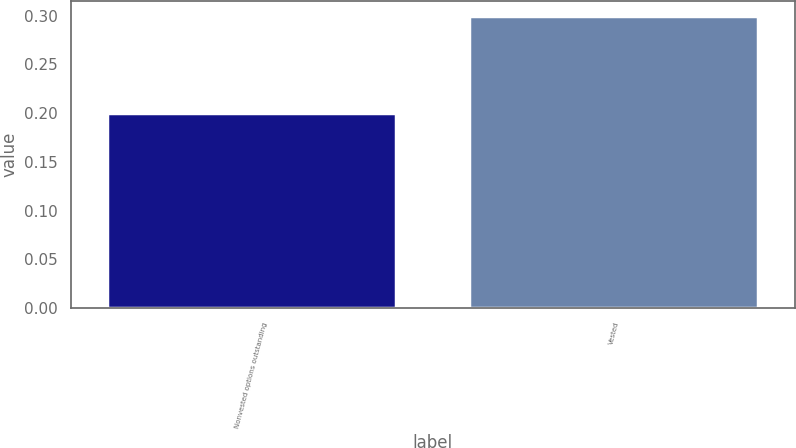<chart> <loc_0><loc_0><loc_500><loc_500><bar_chart><fcel>Nonvested options outstanding<fcel>Vested<nl><fcel>0.2<fcel>0.3<nl></chart> 